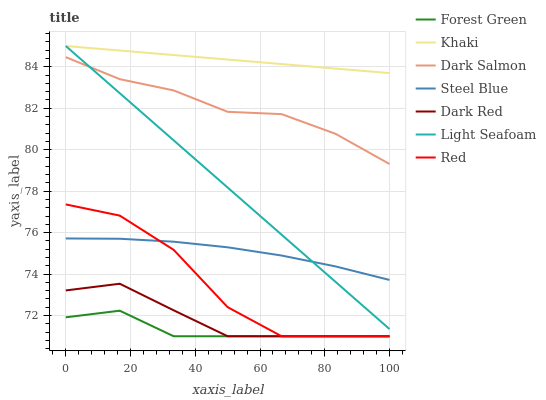Does Forest Green have the minimum area under the curve?
Answer yes or no. Yes. Does Khaki have the maximum area under the curve?
Answer yes or no. Yes. Does Dark Red have the minimum area under the curve?
Answer yes or no. No. Does Dark Red have the maximum area under the curve?
Answer yes or no. No. Is Light Seafoam the smoothest?
Answer yes or no. Yes. Is Red the roughest?
Answer yes or no. Yes. Is Dark Red the smoothest?
Answer yes or no. No. Is Dark Red the roughest?
Answer yes or no. No. Does Dark Red have the lowest value?
Answer yes or no. Yes. Does Dark Salmon have the lowest value?
Answer yes or no. No. Does Light Seafoam have the highest value?
Answer yes or no. Yes. Does Dark Red have the highest value?
Answer yes or no. No. Is Dark Salmon less than Khaki?
Answer yes or no. Yes. Is Khaki greater than Dark Salmon?
Answer yes or no. Yes. Does Light Seafoam intersect Dark Salmon?
Answer yes or no. Yes. Is Light Seafoam less than Dark Salmon?
Answer yes or no. No. Is Light Seafoam greater than Dark Salmon?
Answer yes or no. No. Does Dark Salmon intersect Khaki?
Answer yes or no. No. 